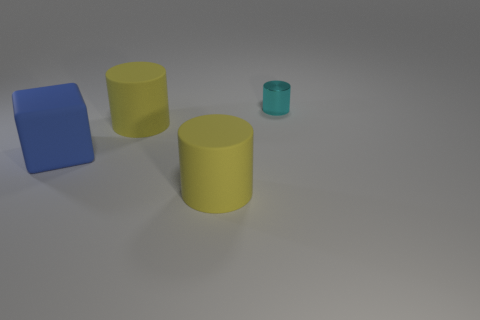Is there anything else that is the same size as the cyan thing?
Offer a terse response. No. How many objects are cylinders in front of the small cyan metal cylinder or things that are left of the tiny cyan metallic cylinder?
Your answer should be very brief. 3. Is there a yellow matte thing that has the same size as the blue rubber thing?
Ensure brevity in your answer.  Yes. Is there a large blue matte cube in front of the yellow rubber object that is in front of the large blue thing?
Your response must be concise. No. Is the shape of the large object in front of the big blue matte block the same as  the cyan metal thing?
Your answer should be very brief. Yes. What is the shape of the tiny metal thing?
Provide a short and direct response. Cylinder. What number of large yellow cylinders are the same material as the tiny cylinder?
Your answer should be compact. 0. What number of large blue cylinders are there?
Your answer should be compact. 0. Is there a rubber thing of the same color as the tiny cylinder?
Offer a very short reply. No. What color is the large matte cylinder that is on the left side of the big yellow matte object that is in front of the yellow object behind the blue block?
Ensure brevity in your answer.  Yellow. 